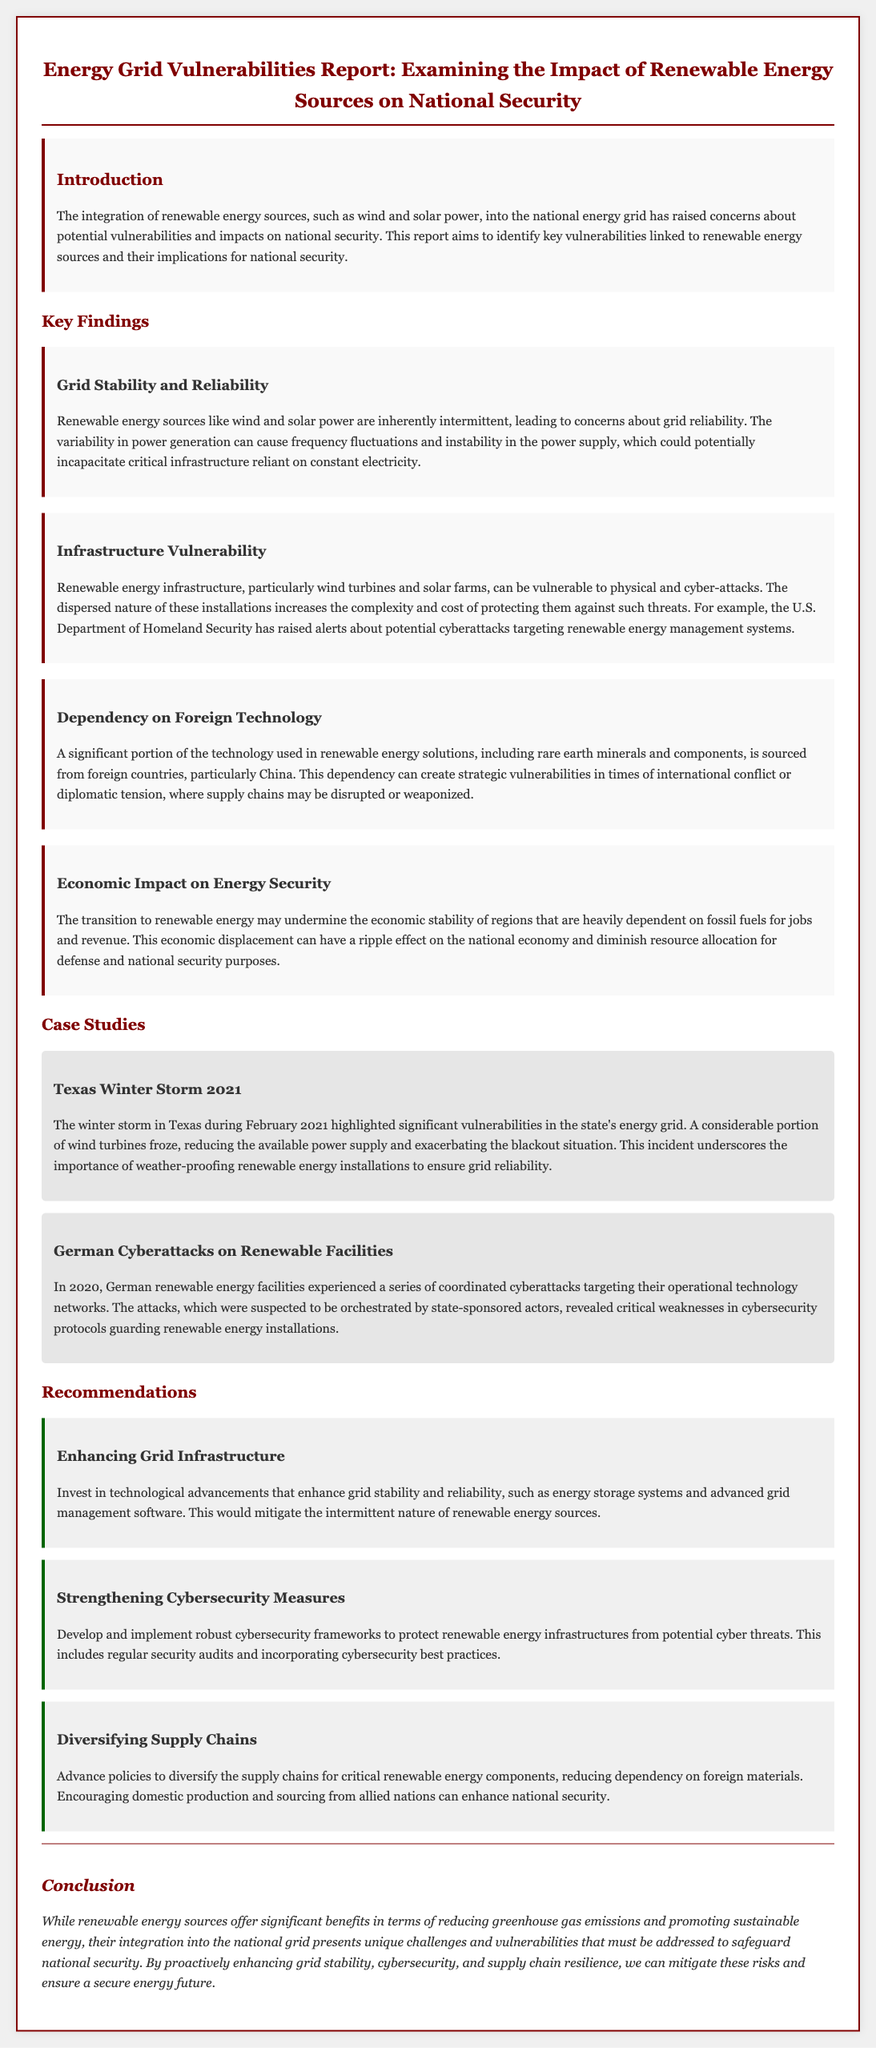What is the title of the report? The title of the report is stated in the heading of the document.
Answer: Energy Grid Vulnerabilities Report: Examining the Impact of Renewable Energy Sources on National Security What are the key findings related to grid stability? The section on grid stability indicates concerns about variability and reliability in power generation.
Answer: Intermittent Which renewable energy sources are mentioned? The introduction states which energy sources the report focuses on.
Answer: Wind and solar power What significant weather event is discussed in relation to energy grid vulnerabilities? The case study section highlights a specific event that affected the energy grid.
Answer: Texas Winter Storm 2021 What recommendation is made for enhancing cybersecurity? The recommendations section suggests a specific step for improving cybersecurity measures.
Answer: Develop and implement robust cybersecurity frameworks What is a dependency highlighted in the report? The report discusses a strategic component related to technology sourcing linked to national security concerns.
Answer: Foreign technology What year did the coordinated cyberattacks in Germany occur? The report specifies the year of the cyberattacks in a case study.
Answer: 2020 What does the conclusion suggest is essential for a secure energy future? The conclusion emphasizes a proactive approach to address vulnerabilities.
Answer: Enhancing grid stability, cybersecurity, and supply chain resilience 